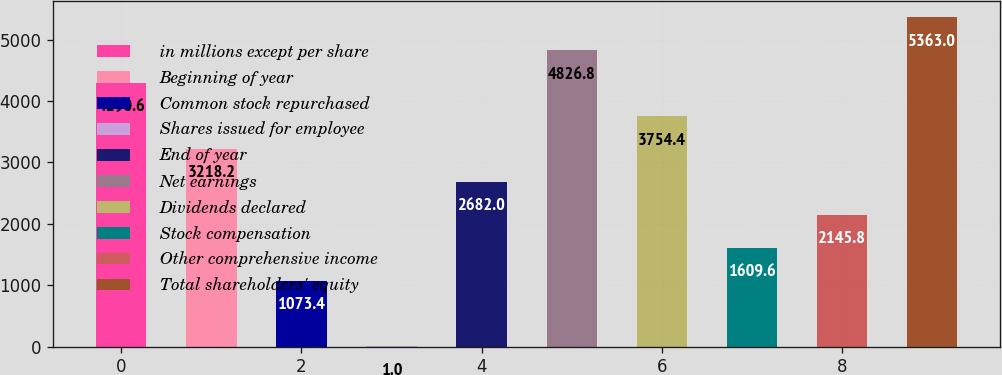Convert chart to OTSL. <chart><loc_0><loc_0><loc_500><loc_500><bar_chart><fcel>in millions except per share<fcel>Beginning of year<fcel>Common stock repurchased<fcel>Shares issued for employee<fcel>End of year<fcel>Net earnings<fcel>Dividends declared<fcel>Stock compensation<fcel>Other comprehensive income<fcel>Total shareholders' equity<nl><fcel>4290.6<fcel>3218.2<fcel>1073.4<fcel>1<fcel>2682<fcel>4826.8<fcel>3754.4<fcel>1609.6<fcel>2145.8<fcel>5363<nl></chart> 